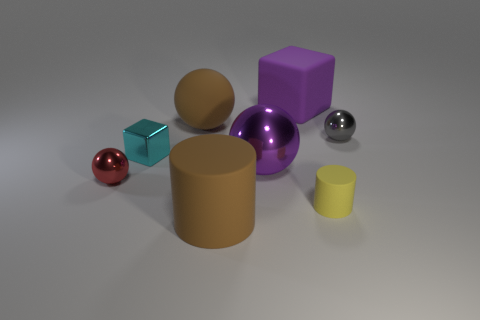Does the big purple block have the same material as the yellow cylinder?
Offer a very short reply. Yes. What number of purple objects are large matte balls or balls?
Give a very brief answer. 1. Is the number of big brown things that are in front of the cyan metal block greater than the number of large yellow metallic cylinders?
Your response must be concise. Yes. Are there any large spheres that have the same color as the large block?
Your answer should be very brief. Yes. How big is the rubber block?
Your answer should be compact. Large. Is the big metal object the same color as the big cube?
Your response must be concise. Yes. How many things are either shiny cylinders or small metal balls on the left side of the yellow cylinder?
Make the answer very short. 1. There is a brown thing that is in front of the small shiny ball to the left of the cyan cube; what number of cylinders are behind it?
Your answer should be very brief. 1. There is a large thing that is the same color as the big matte cube; what is it made of?
Offer a terse response. Metal. What number of shiny balls are there?
Keep it short and to the point. 3. 